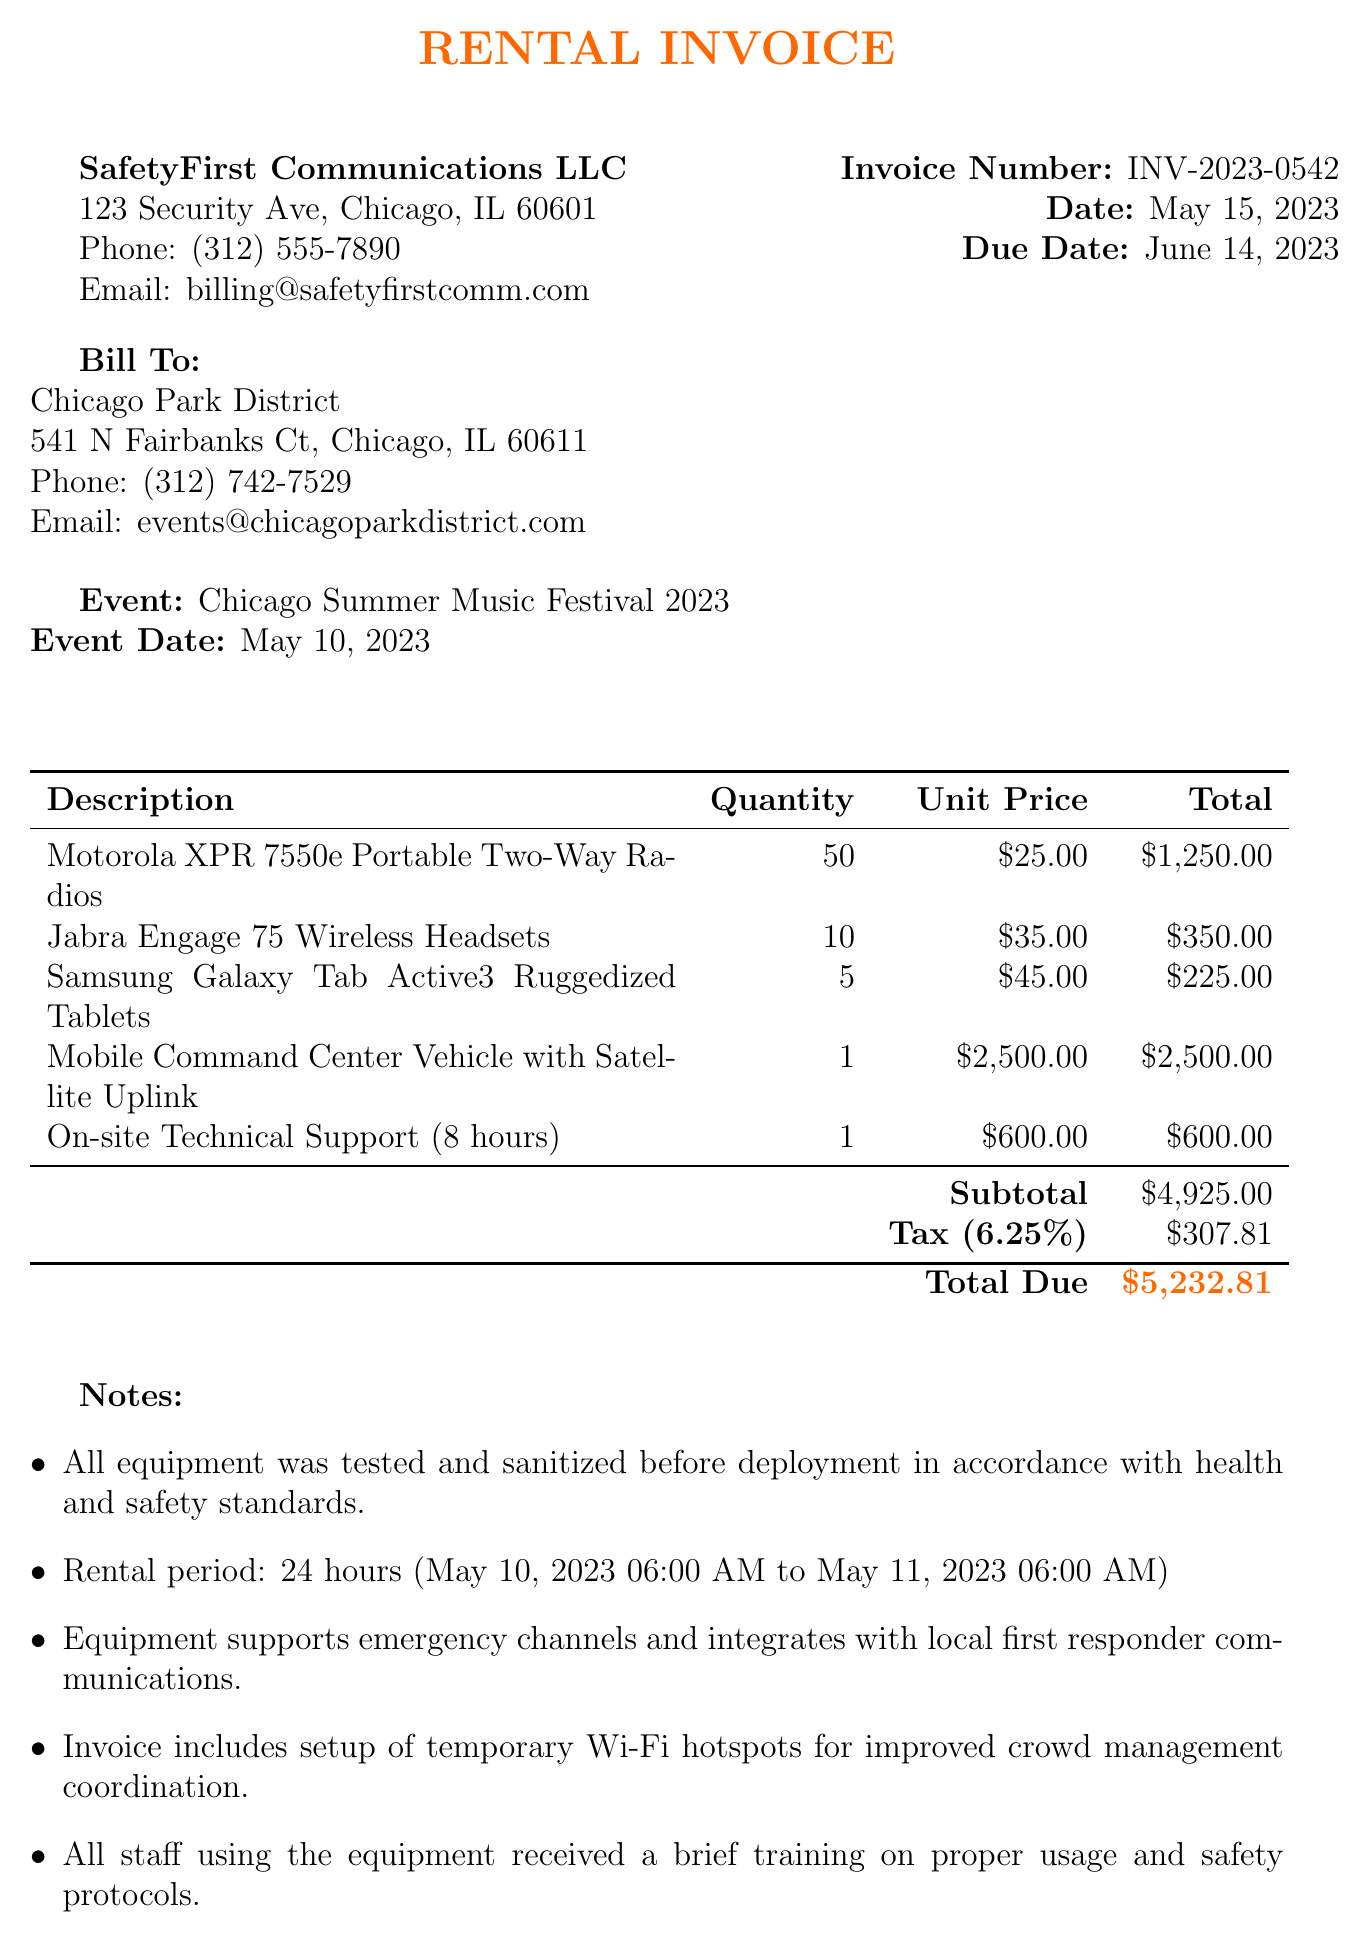What is the invoice number? The invoice number is stated at the top of the document under the invoice details section.
Answer: INV-2023-0542 What is the total amount due? The total amount due is calculated from the subtotal plus tax.
Answer: $5,232.81 Which company provided the rental equipment? The billing company is listed prominently in the header section of the document.
Answer: SafetyFirst Communications LLC How many Motorola XPR 7550e Portable Two-Way Radios were rented? The quantity of each item is mentioned in the itemized list of the invoice.
Answer: 50 What is the rental period for the equipment? The rental period is specified in the notes section of the invoice.
Answer: 24 hours (May 10, 2023 06:00 AM to May 11, 2023 06:00 AM) What is the tax rate applied to the invoice? The tax rate is mentioned directly in the itemized financial summary.
Answer: 6.25% What type of payment methods are accepted? The payment methods are listed in the payment terms section of the invoice.
Answer: Check, ACH Transfer, Credit Card What support service was included in the rental? The items listed include any additional services provided with the equipment.
Answer: On-site Technical Support (8 hours) How many Samsung Galaxy Tab Active3 Ruggedized Tablets were rented? The quantity of different mobile communication devices rented is detailed in the itemized section of the invoice.
Answer: 5 